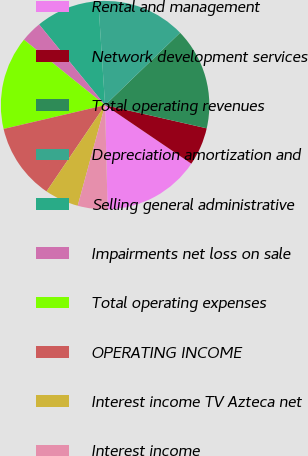Convert chart. <chart><loc_0><loc_0><loc_500><loc_500><pie_chart><fcel>Rental and management<fcel>Network development services<fcel>Total operating revenues<fcel>Depreciation amortization and<fcel>Selling general administrative<fcel>Impairments net loss on sale<fcel>Total operating expenses<fcel>OPERATING INCOME<fcel>Interest income TV Azteca net<fcel>Interest income<nl><fcel>15.13%<fcel>5.92%<fcel>15.79%<fcel>13.82%<fcel>9.87%<fcel>3.29%<fcel>14.47%<fcel>11.84%<fcel>5.26%<fcel>4.61%<nl></chart> 